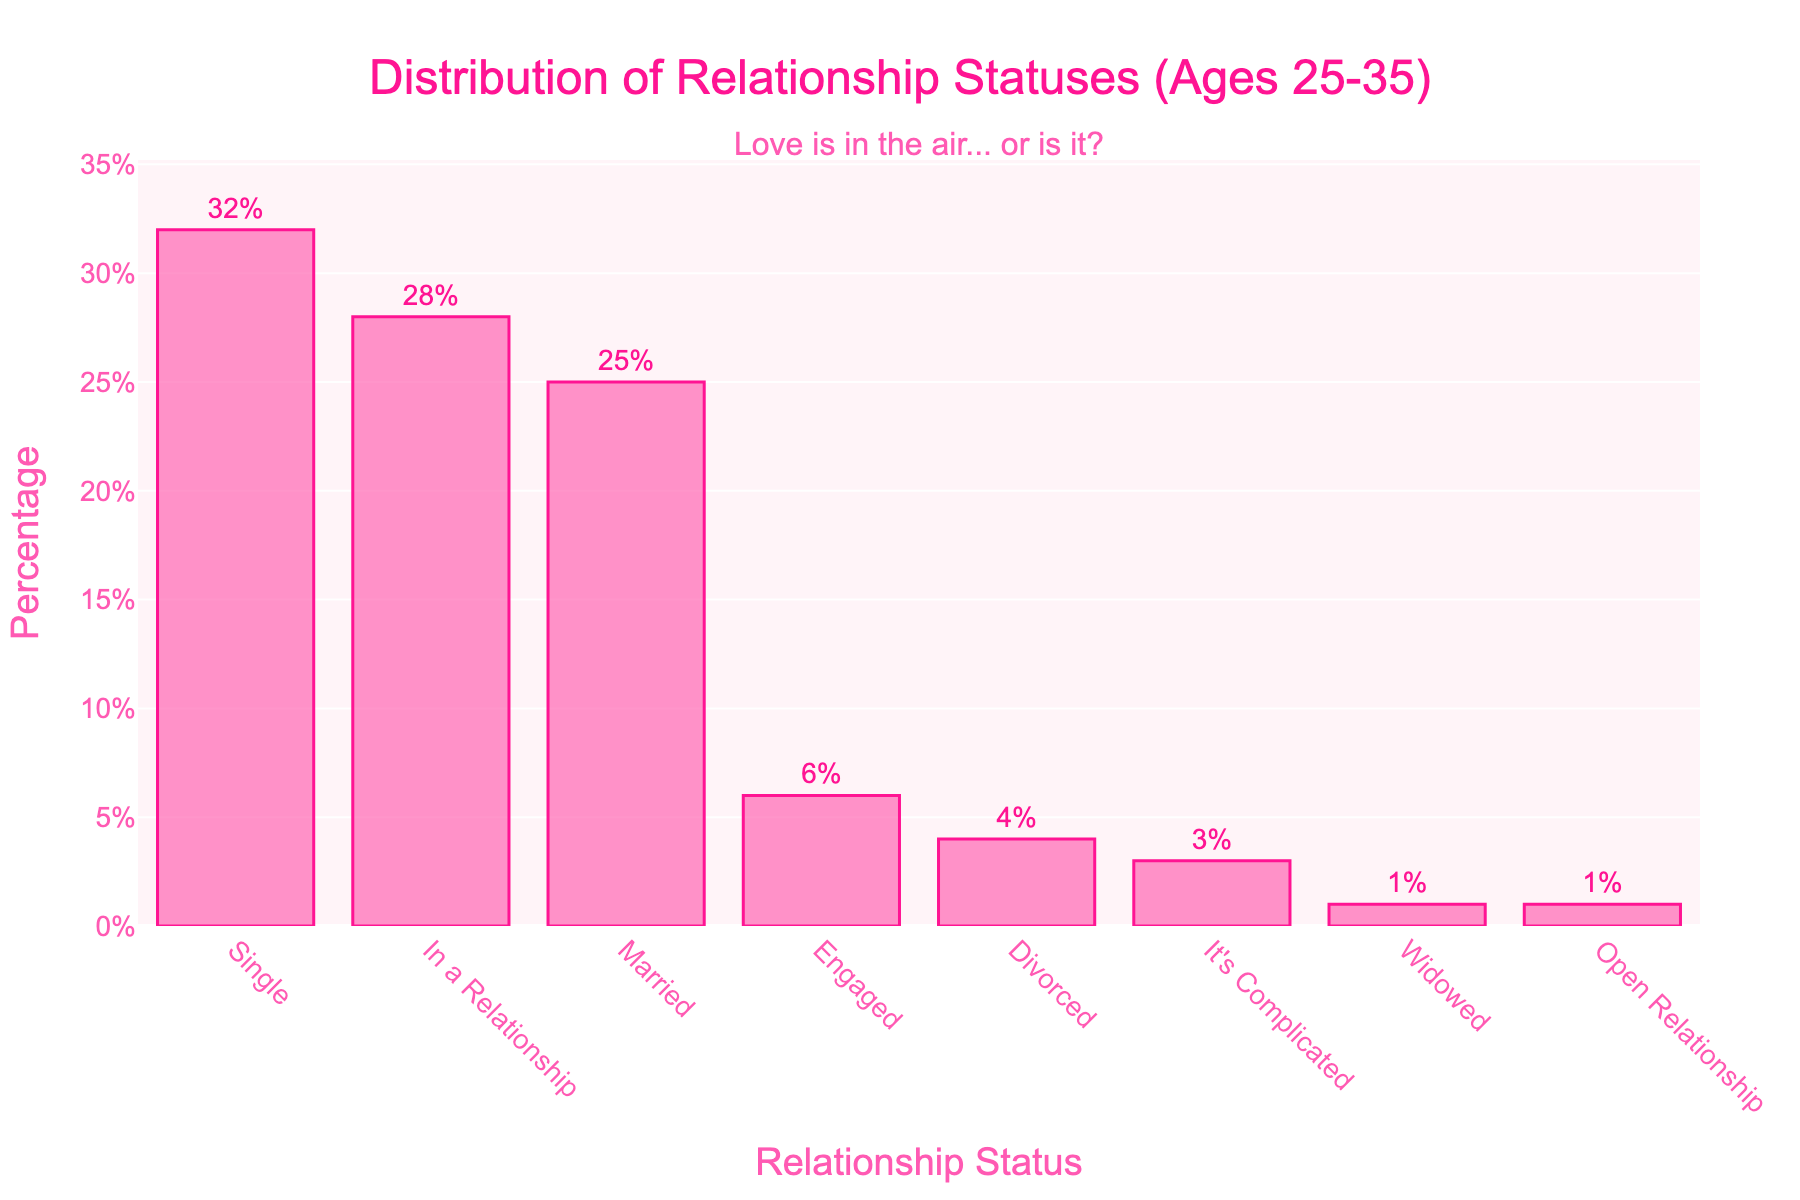What percentage of adults aged 25-35 are either married or engaged? Add the percentage of adults who are married (25%) to the percentage of those who are engaged (6%) to get the total.
Answer: 31% Which relationship status has the second-highest percentage in the given age group? From the chart, the highest percentage is single (32%), and the second highest is in a relationship (28%).
Answer: In a relationship How many relationship statues have a percentage lower than 5%? Count the bars representing percentages lower than 5%, which are: Divorced (4%), It's Complicated (3%), Open Relationship (1%), and Widowed (1%). That's a total of 4 categories.
Answer: 4 What is the percentage difference between people who are single and married? Subtract the percentage of married people (25%) from the percentage of single people (32%) to get the difference (32% - 25%).
Answer: 7% Compare the percentages of people in an open relationship and those who are widowed. Which category has a higher percentage and by how much? Both categories have the same percentage of 1%, resulting in no difference.
Answer: Equal, 0% What is the combined percentage of people whose relationship status is either "It's Complicated" or "Divorced"? Add the percentage for "It's Complicated" (3%) and "Divorced" (4%) to get the total (3% + 4%).
Answer: 7% Which relationship status has exactly half of the percentage points of those who are single? Calculate half of the single percentage (32%), which is 16%. Then, check if any percentage matches this value, which it does not.
Answer: None Arrange the relationship status categories in descending order of their percentages. The ordering from highest to lowest is: Single (32%), In a Relationship (28%), Married (25%), Engaged (6%), Divorced (4%), It's Complicated (3%), Open Relationship (1%), Widowed (1%).
Answer: Single > In a Relationship > Married > Engaged > Divorced > It's Complicated > Open Relationship > Widowed If you were to combine the categories "Widowed" and "Open Relationship," what would be their total percentage and would it exceed the percentage of "Engaged"? Add the percentages of "Widowed" (1%) and "Open Relationship" (1%) to get 2%. Since 2% is less than 6%, it does not exceed the "Engaged" percentage.
Answer: 2%, No 